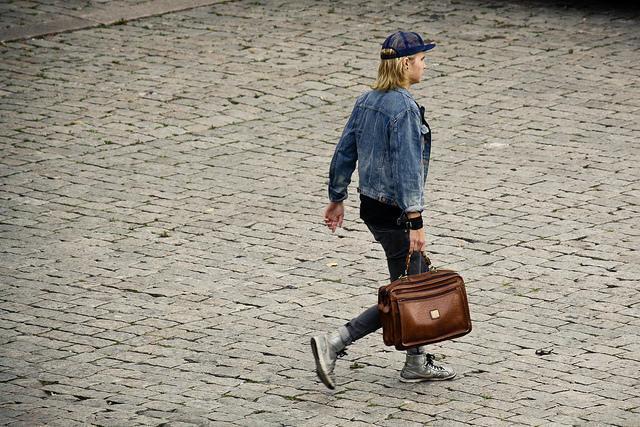How many feet are shown?
Give a very brief answer. 2. 